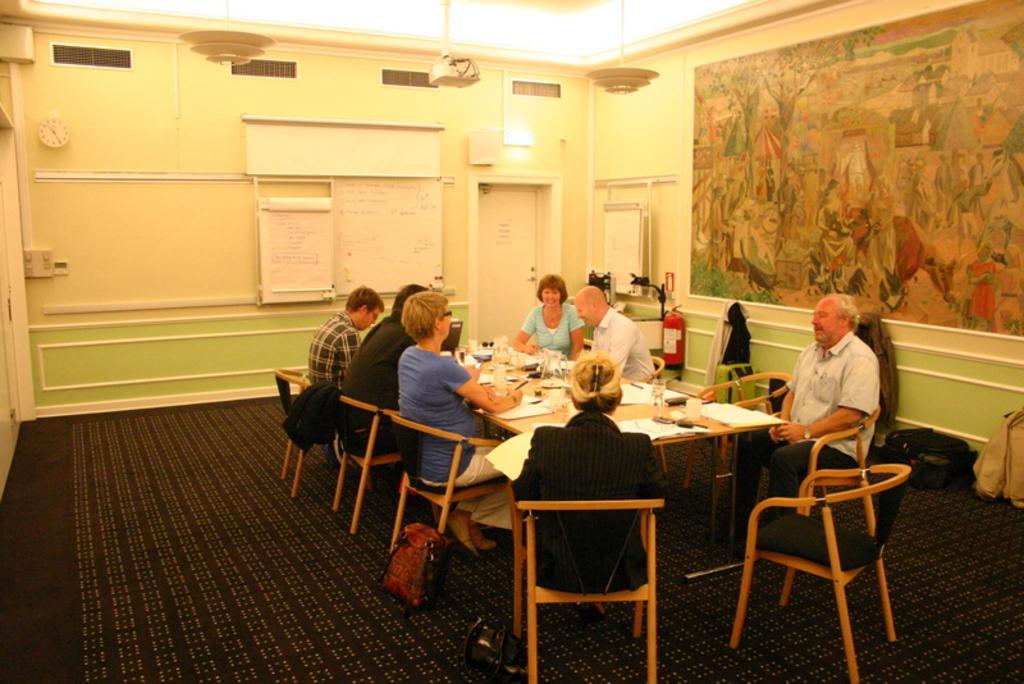In one or two sentences, can you explain what this image depicts? This picture is clicked inside the room. Here, we see seven people sitting on either side of the table. On table, we see glass, paper, mobile phone and jar. Beside them, we see a white wall on which white board is placed and beside that, we see a white door and on right corner of picture, we see colorful poster. 